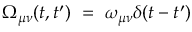Convert formula to latex. <formula><loc_0><loc_0><loc_500><loc_500>\Omega _ { \mu \nu } ( t , t ^ { \prime } ) = \omega _ { \mu \nu } \delta ( t - t ^ { \prime } )</formula> 